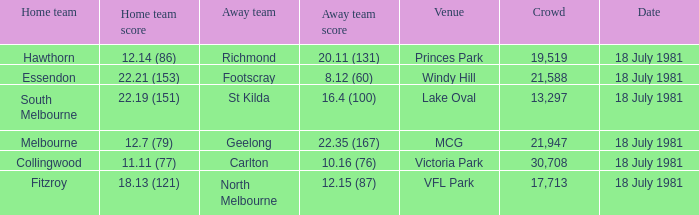What was the away team that played against Fitzroy? North Melbourne. 